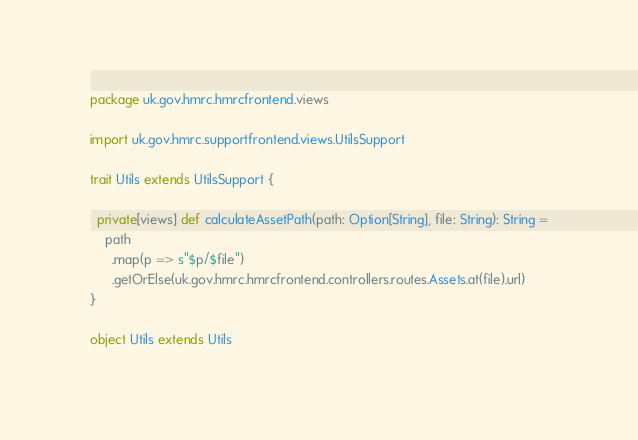<code> <loc_0><loc_0><loc_500><loc_500><_Scala_>
package uk.gov.hmrc.hmrcfrontend.views

import uk.gov.hmrc.supportfrontend.views.UtilsSupport

trait Utils extends UtilsSupport {

  private[views] def calculateAssetPath(path: Option[String], file: String): String =
    path
      .map(p => s"$p/$file")
      .getOrElse(uk.gov.hmrc.hmrcfrontend.controllers.routes.Assets.at(file).url)
}

object Utils extends Utils
</code> 